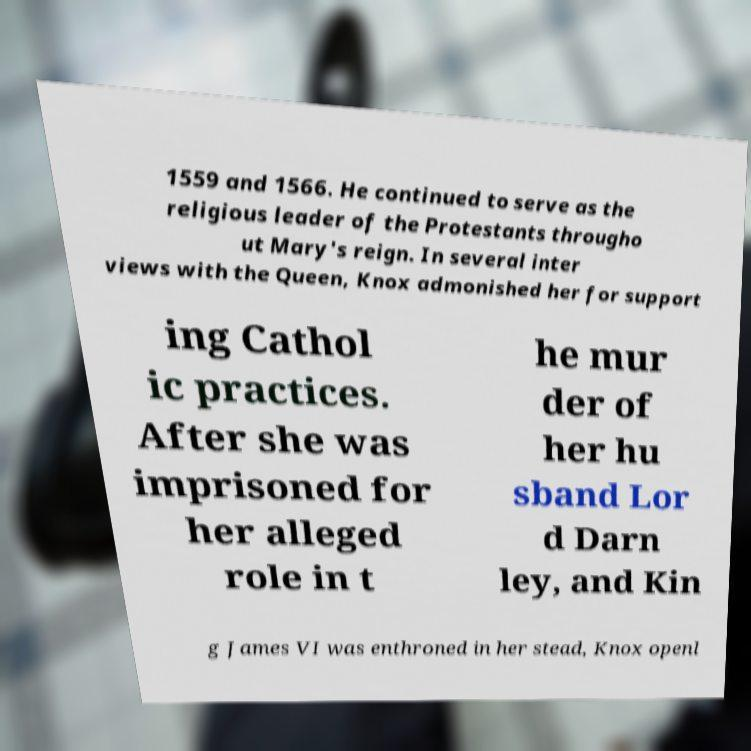What messages or text are displayed in this image? I need them in a readable, typed format. 1559 and 1566. He continued to serve as the religious leader of the Protestants througho ut Mary's reign. In several inter views with the Queen, Knox admonished her for support ing Cathol ic practices. After she was imprisoned for her alleged role in t he mur der of her hu sband Lor d Darn ley, and Kin g James VI was enthroned in her stead, Knox openl 